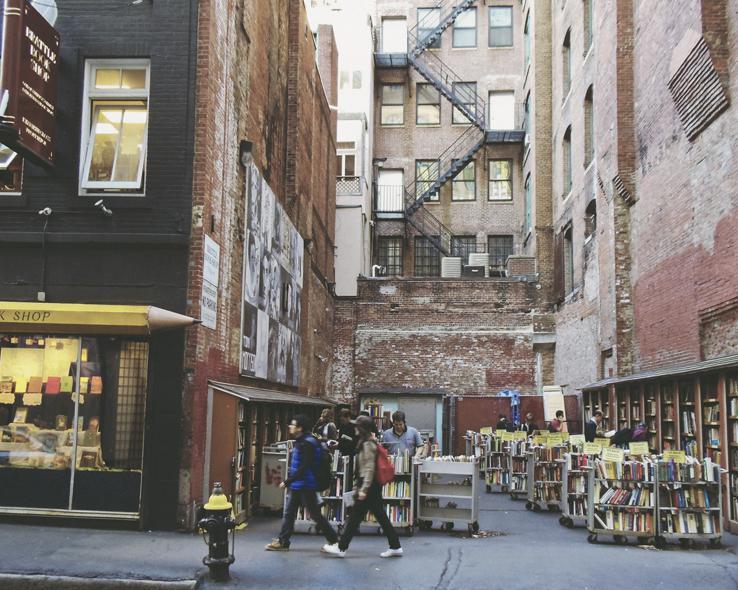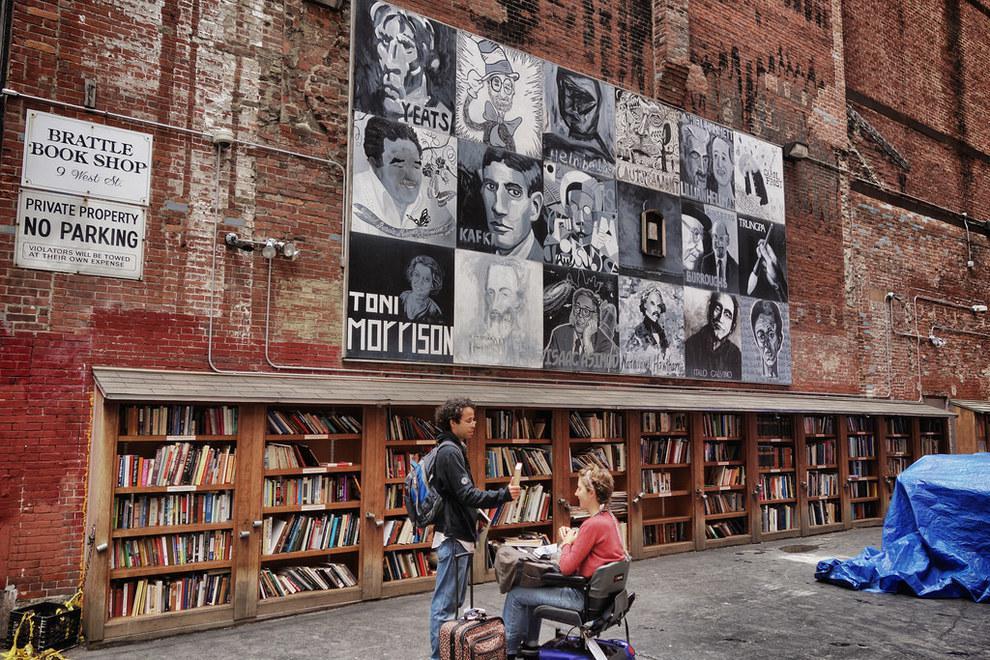The first image is the image on the left, the second image is the image on the right. Considering the images on both sides, is "Right image shows people browsing bookshelves topped with orange signs, located in a space partly surrounded by brick walls." valid? Answer yes or no. No. 